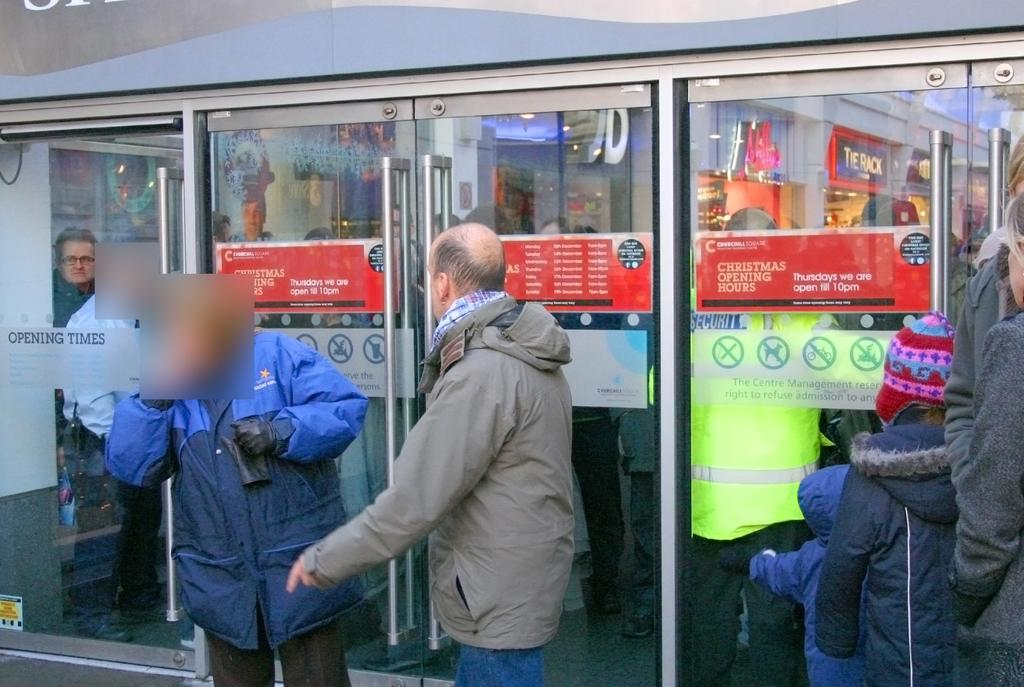What is happening in the image? There are people standing in front of a store. What can be seen on the glass doors in the background? There are posters on the glass doors in the background. How do the waves affect the action in the image? There are no waves or actions related to waves in the image; it features people standing in front of a store and posters on glass doors. 